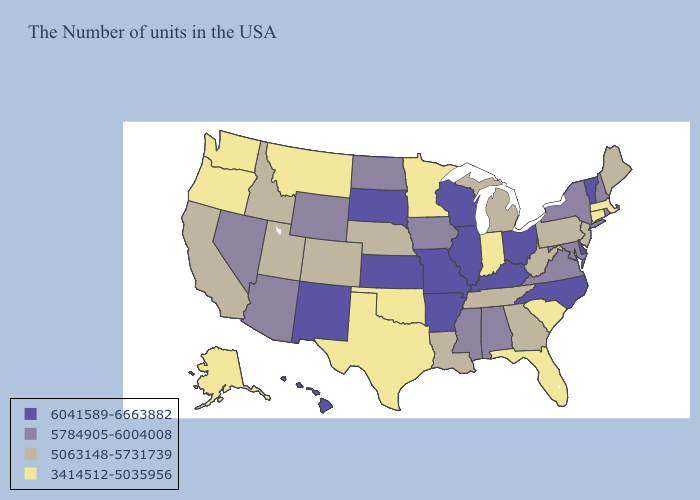Name the states that have a value in the range 6041589-6663882?
Concise answer only. Vermont, Delaware, North Carolina, Ohio, Kentucky, Wisconsin, Illinois, Missouri, Arkansas, Kansas, South Dakota, New Mexico, Hawaii. Does Vermont have a higher value than Missouri?
Concise answer only. No. What is the value of New Mexico?
Write a very short answer. 6041589-6663882. What is the lowest value in the South?
Write a very short answer. 3414512-5035956. What is the value of Louisiana?
Keep it brief. 5063148-5731739. How many symbols are there in the legend?
Be succinct. 4. Which states hav the highest value in the South?
Concise answer only. Delaware, North Carolina, Kentucky, Arkansas. Does Utah have a higher value than Texas?
Be succinct. Yes. What is the value of Kansas?
Write a very short answer. 6041589-6663882. What is the highest value in the USA?
Be succinct. 6041589-6663882. What is the value of Wisconsin?
Short answer required. 6041589-6663882. What is the value of California?
Give a very brief answer. 5063148-5731739. Among the states that border Georgia , does Florida have the lowest value?
Answer briefly. Yes. Name the states that have a value in the range 3414512-5035956?
Keep it brief. Massachusetts, Connecticut, South Carolina, Florida, Indiana, Minnesota, Oklahoma, Texas, Montana, Washington, Oregon, Alaska. Name the states that have a value in the range 6041589-6663882?
Concise answer only. Vermont, Delaware, North Carolina, Ohio, Kentucky, Wisconsin, Illinois, Missouri, Arkansas, Kansas, South Dakota, New Mexico, Hawaii. 